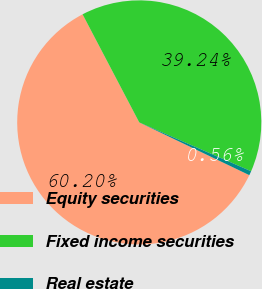<chart> <loc_0><loc_0><loc_500><loc_500><pie_chart><fcel>Equity securities<fcel>Fixed income securities<fcel>Real estate<nl><fcel>60.2%<fcel>39.24%<fcel>0.56%<nl></chart> 